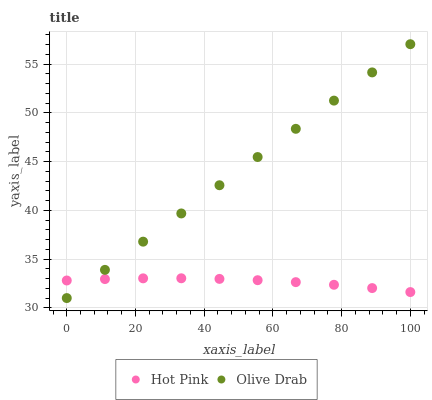Does Hot Pink have the minimum area under the curve?
Answer yes or no. Yes. Does Olive Drab have the maximum area under the curve?
Answer yes or no. Yes. Does Olive Drab have the minimum area under the curve?
Answer yes or no. No. Is Olive Drab the smoothest?
Answer yes or no. Yes. Is Hot Pink the roughest?
Answer yes or no. Yes. Is Olive Drab the roughest?
Answer yes or no. No. Does Olive Drab have the lowest value?
Answer yes or no. Yes. Does Olive Drab have the highest value?
Answer yes or no. Yes. Does Hot Pink intersect Olive Drab?
Answer yes or no. Yes. Is Hot Pink less than Olive Drab?
Answer yes or no. No. Is Hot Pink greater than Olive Drab?
Answer yes or no. No. 